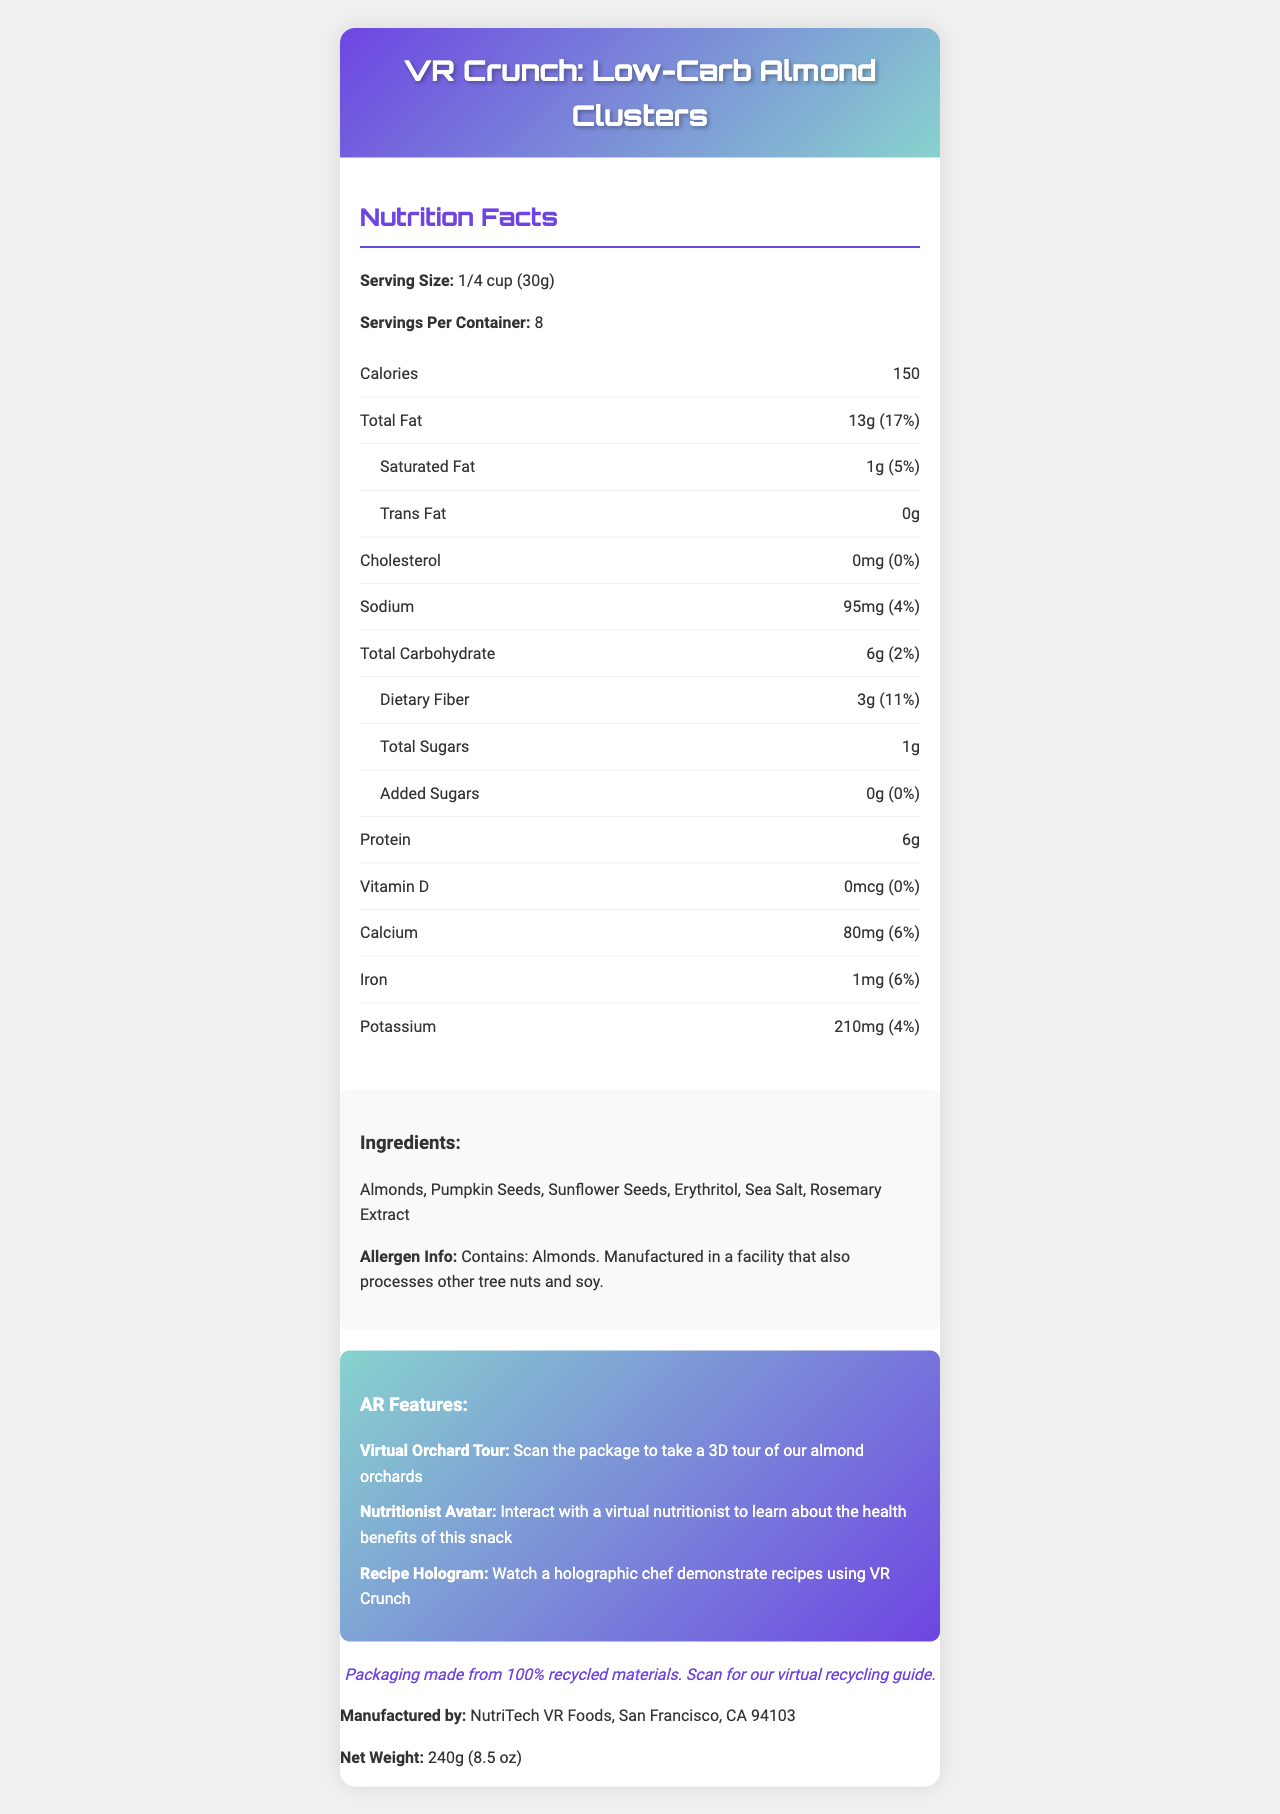what is the serving size? The serving size is explicitly stated in the 'Nutrition Facts' section of the document.
Answer: 1/4 cup (30g) how many calories are there per serving? The calories per serving are listed as 150 in the 'Nutrition Facts' section.
Answer: 150 what amount of dietary fiber is present in each serving? The dietary fiber amount is shown as 3g in the 'Nutrition Facts' section.
Answer: 3g how many servings are there per container? The 'Nutrition Facts' section mentions that there are 8 servings per container.
Answer: 8 who manufactures the VR Crunch? The manufacturer's information is provided toward the end of the document.
Answer: NutriTech VR Foods, San Francisco, CA 94103 What is the total fat content per serving and its daily value? The total fat content and its daily value per serving are given in the 'Nutrition Facts' section as 13g and 17% respectively.
Answer: 13g (17%) How much sodium is in each serving? The sodium content per serving is listed as 95mg in the 'Nutrition Facts' section.
Answer: 95mg Which ingredient is stated as containing an allergen? The allergen information mentions that the product contains almonds.
Answer: Almonds What are the three augmented reality features listed on the packaging? A. Virtual Orchard Tour, Recipe Hologram, Interactive Game B. Virtual Orchard Tour, Nutritionist Avatar, Recipe Hologram C. Virtual Orchard Tour, Zara's VR Experience, Recipe Hologram D. Recipe Hologram, Nutritionist Avatar, Interactive Game The three augmented reality features mentioned are 'Virtual Orchard Tour', 'Nutritionist Avatar', and 'Recipe Hologram'.
Answer: B How much added sugar is in a serving of VR Crunch? A. 1g B. 2g C. 0g D. 5g The added sugars per serving are listed as 0g in the 'Nutrition Facts' section.
Answer: C Is there any cholesterol in VR Crunch? The 'Nutrition Facts' section shows that the cholesterol content is 0mg, indicating there is no cholesterol.
Answer: No Summarize the main features of VR Crunch: Low-Carb Almond Clusters. VR Crunch: Low-Carb Almond Clusters offers a nutrient-rich, low-carb snack with advanced packaging featuring augmented reality experiences. The AR features enhance user interaction, providing both educational and entertaining elements. The product emphasizes sustainability with recycled materials and is creatively designed, drawing inspiration from early CGI work.
Answer: VR Crunch: Low-Carb Almond Clusters is a snack with low carbohydrates and designed using AR technology. It contains various nutrients, including 13g of total fat, 3g of dietary fiber, and 6g of protein per serving. The product has augmented reality features such as a virtual orchard tour, a nutritionist avatar, and a recipe hologram. The low-carb snack is manufactured by NutriTech VR Foods in San Francisco and comes in recycled packaging. The design is inspired by early computer-generated imagery, making it visually appealing. What is the inspiration behind the packaging design? The document explains that the packaging design is inspired by the creator's parent's work in early computer-generated imagery.
Answer: Packaging design inspired by my parent's groundbreaking work in early computer-generated imagery, reimagined for the AR era Where should you go to learn about the health benefits of VR Crunch using augmented reality? The AR details section mentions the 'Nutritionist Avatar' feature, which helps in learning about the health benefits.
Answer: Interact with the virtual nutritionist How much potassium is there in a serving, and what is its daily value percentage? The potassium content per serving is listed as 210mg and its daily value is 4% in the 'Nutrition Facts' section.
Answer: 210mg (4%) What is the proportion of almonds among the ingredients? The document does not provide specific proportions of each ingredient, thus it is impossible to determine the exact proportion of almonds.
Answer: Not enough information 